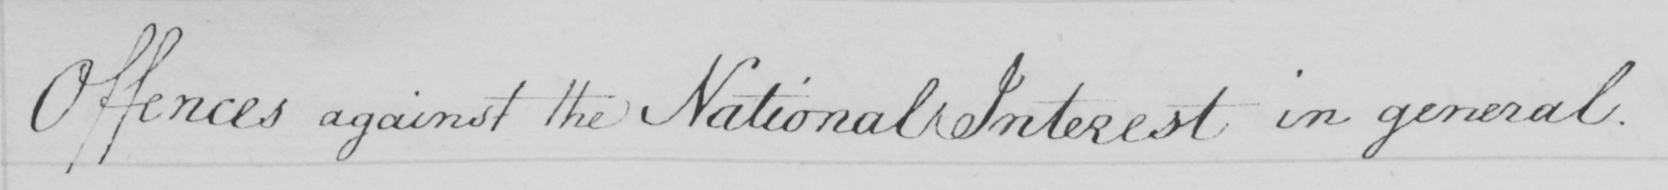Can you read and transcribe this handwriting? Offences against the National Interest in general . 